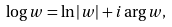<formula> <loc_0><loc_0><loc_500><loc_500>\log w = \ln | w | + i \arg w ,</formula> 